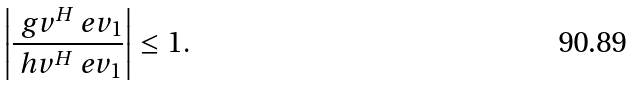<formula> <loc_0><loc_0><loc_500><loc_500>\left | \frac { \ g v ^ { H } \ e v _ { 1 } } { \ h v ^ { H } \ e v _ { 1 } } \right | \leq 1 .</formula> 